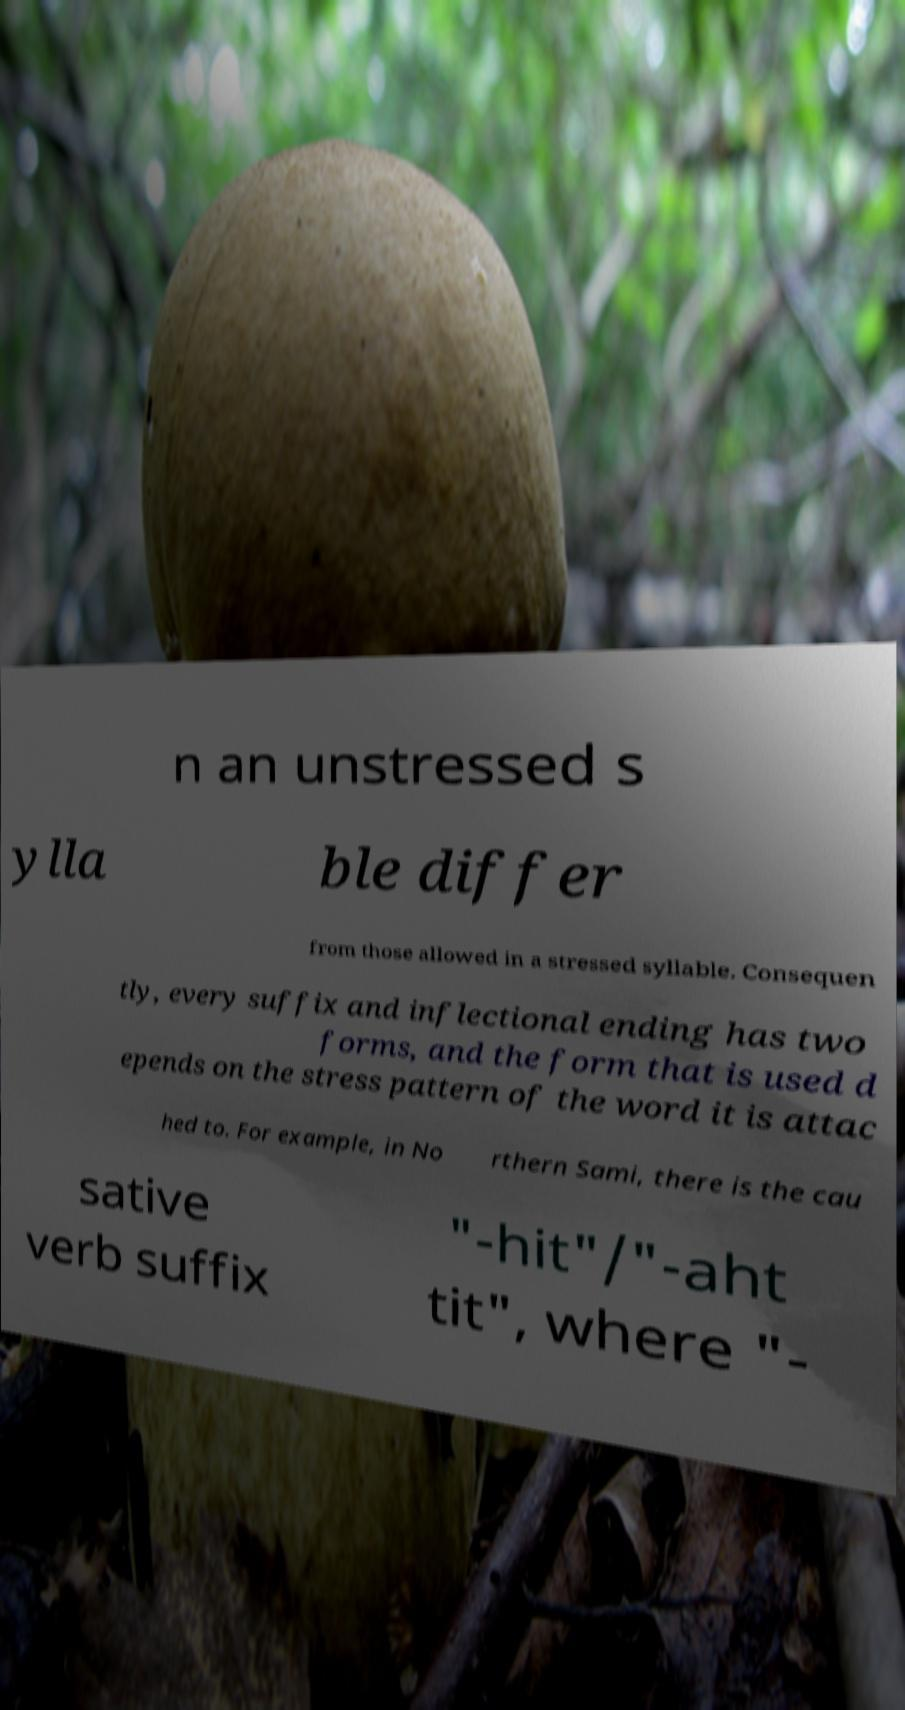Can you read and provide the text displayed in the image?This photo seems to have some interesting text. Can you extract and type it out for me? n an unstressed s ylla ble differ from those allowed in a stressed syllable. Consequen tly, every suffix and inflectional ending has two forms, and the form that is used d epends on the stress pattern of the word it is attac hed to. For example, in No rthern Sami, there is the cau sative verb suffix "-hit"/"-aht tit", where "- 